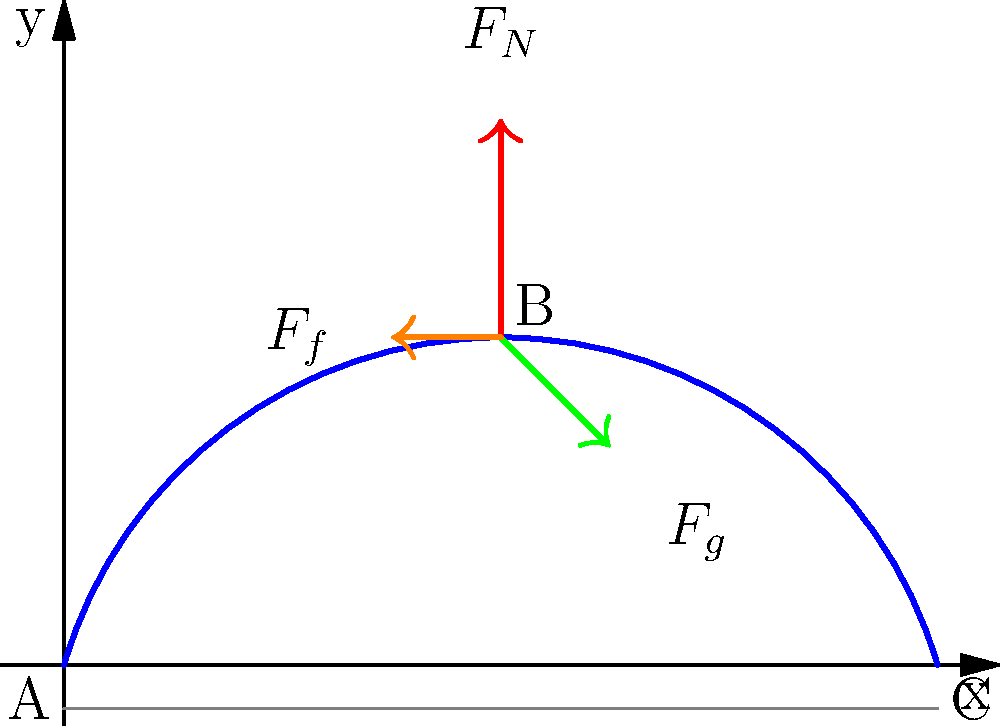During an ollie, a skateboarder follows the trajectory shown in the diagram. At point B, which represents the peak of the ollie, identify the primary forces acting on the skateboarder and explain how they contribute to the motion. What is the relationship between these forces at this point? To analyze the forces acting on the skateboarder during an ollie at point B (the peak of the trajectory), we need to consider the following:

1. Identify the forces:
   a) Normal force ($F_N$): Upward force exerted by the skateboard on the skateboarder.
   b) Gravitational force ($F_g$): Downward force due to the Earth's gravity.
   c) Friction force ($F_f$): Horizontal force opposing the motion.

2. Analyze each force:
   a) $F_N$: At the peak of the ollie, the normal force is at its minimum but still present as the skateboarder is in contact with the board.
   b) $F_g$: The gravitational force is constant throughout the motion, always pointing downward.
   c) $F_f$: Friction is minimal at this point but still present due to air resistance.

3. Consider the vertical motion:
   At the peak (point B), the vertical velocity is momentarily zero.
   $$ \sum F_y = F_N - F_g = ma_y = 0 $$
   This implies that $F_N = F_g$ at this instant.

4. Consider the horizontal motion:
   The horizontal velocity is decreasing due to air resistance.
   $$ \sum F_x = -F_f = ma_x $$
   Where $a_x$ is negative, indicating deceleration.

5. Relationship between forces:
   At point B, the normal force and gravitational force are equal in magnitude but opposite in direction, resulting in zero vertical acceleration. The friction force is the only horizontal force, causing a slight deceleration in the x-direction.
Answer: At point B: $F_N = F_g$, $F_f$ causes horizontal deceleration. 